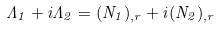Convert formula to latex. <formula><loc_0><loc_0><loc_500><loc_500>\Lambda _ { 1 } + i \Lambda _ { 2 } = ( N _ { 1 } ) _ { , r } + i ( N _ { 2 } ) _ { , r }</formula> 